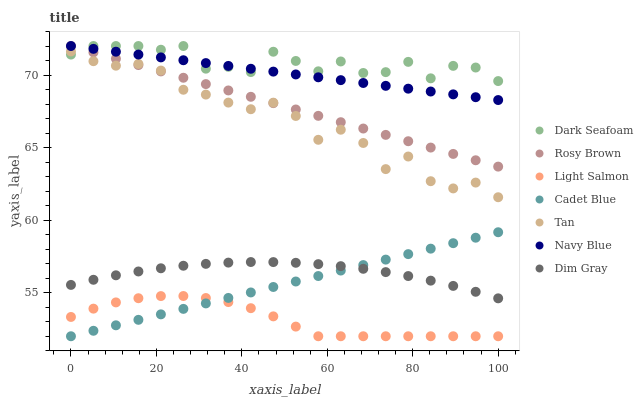Does Light Salmon have the minimum area under the curve?
Answer yes or no. Yes. Does Dark Seafoam have the maximum area under the curve?
Answer yes or no. Yes. Does Cadet Blue have the minimum area under the curve?
Answer yes or no. No. Does Cadet Blue have the maximum area under the curve?
Answer yes or no. No. Is Navy Blue the smoothest?
Answer yes or no. Yes. Is Tan the roughest?
Answer yes or no. Yes. Is Cadet Blue the smoothest?
Answer yes or no. No. Is Cadet Blue the roughest?
Answer yes or no. No. Does Light Salmon have the lowest value?
Answer yes or no. Yes. Does Navy Blue have the lowest value?
Answer yes or no. No. Does Dark Seafoam have the highest value?
Answer yes or no. Yes. Does Cadet Blue have the highest value?
Answer yes or no. No. Is Cadet Blue less than Tan?
Answer yes or no. Yes. Is Rosy Brown greater than Dim Gray?
Answer yes or no. Yes. Does Cadet Blue intersect Dim Gray?
Answer yes or no. Yes. Is Cadet Blue less than Dim Gray?
Answer yes or no. No. Is Cadet Blue greater than Dim Gray?
Answer yes or no. No. Does Cadet Blue intersect Tan?
Answer yes or no. No. 